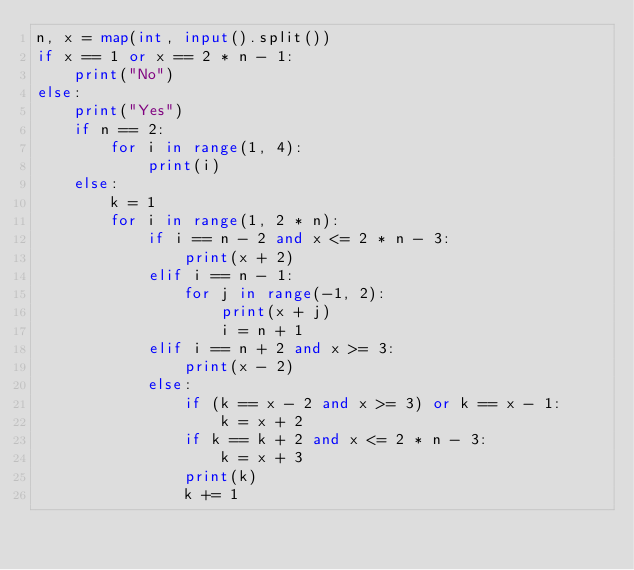Convert code to text. <code><loc_0><loc_0><loc_500><loc_500><_Python_>n, x = map(int, input().split())
if x == 1 or x == 2 * n - 1:
    print("No")
else:
    print("Yes")
    if n == 2:
        for i in range(1, 4):
            print(i)
    else:
        k = 1
        for i in range(1, 2 * n):
            if i == n - 2 and x <= 2 * n - 3:
                print(x + 2)
            elif i == n - 1:
                for j in range(-1, 2):
                    print(x + j)
                    i = n + 1
            elif i == n + 2 and x >= 3:
                print(x - 2)
            else:
                if (k == x - 2 and x >= 3) or k == x - 1:
                    k = x + 2
                if k == k + 2 and x <= 2 * n - 3:
                    k = x + 3
                print(k)
                k += 1</code> 